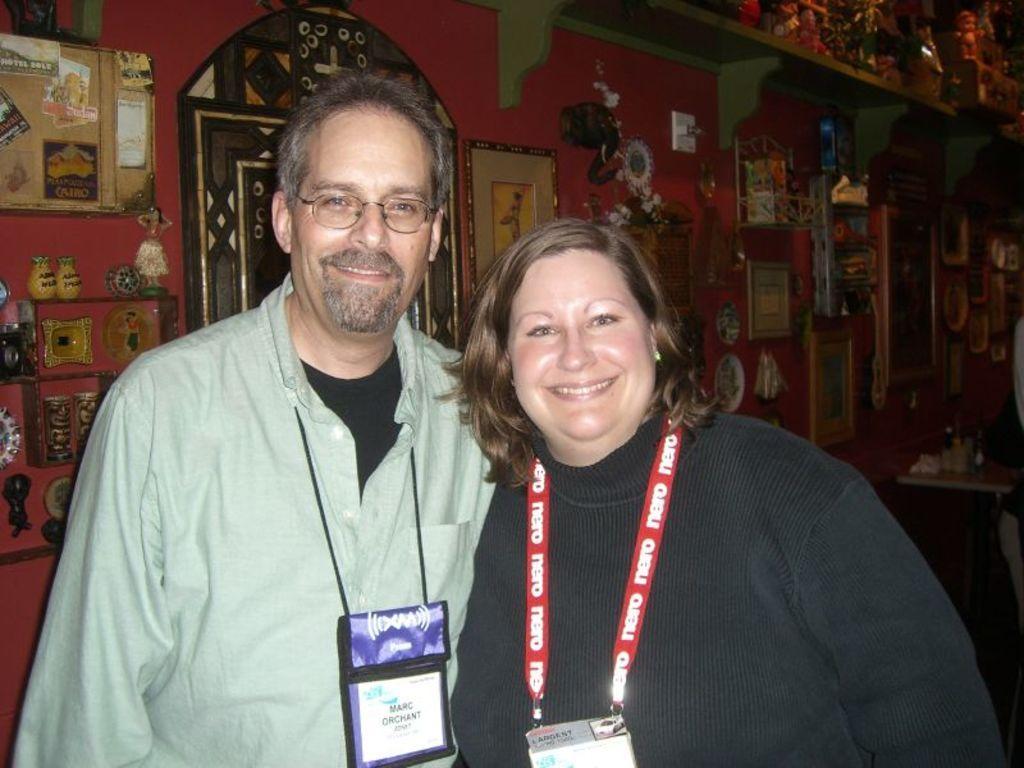Please provide a concise description of this image. In this image I can see two people with green and black color dresses. In the background I can see few objects on the shelves. I can see the frames, boards and many objects are attached to the wall. At the top I can see the few more objects on the shelf. 